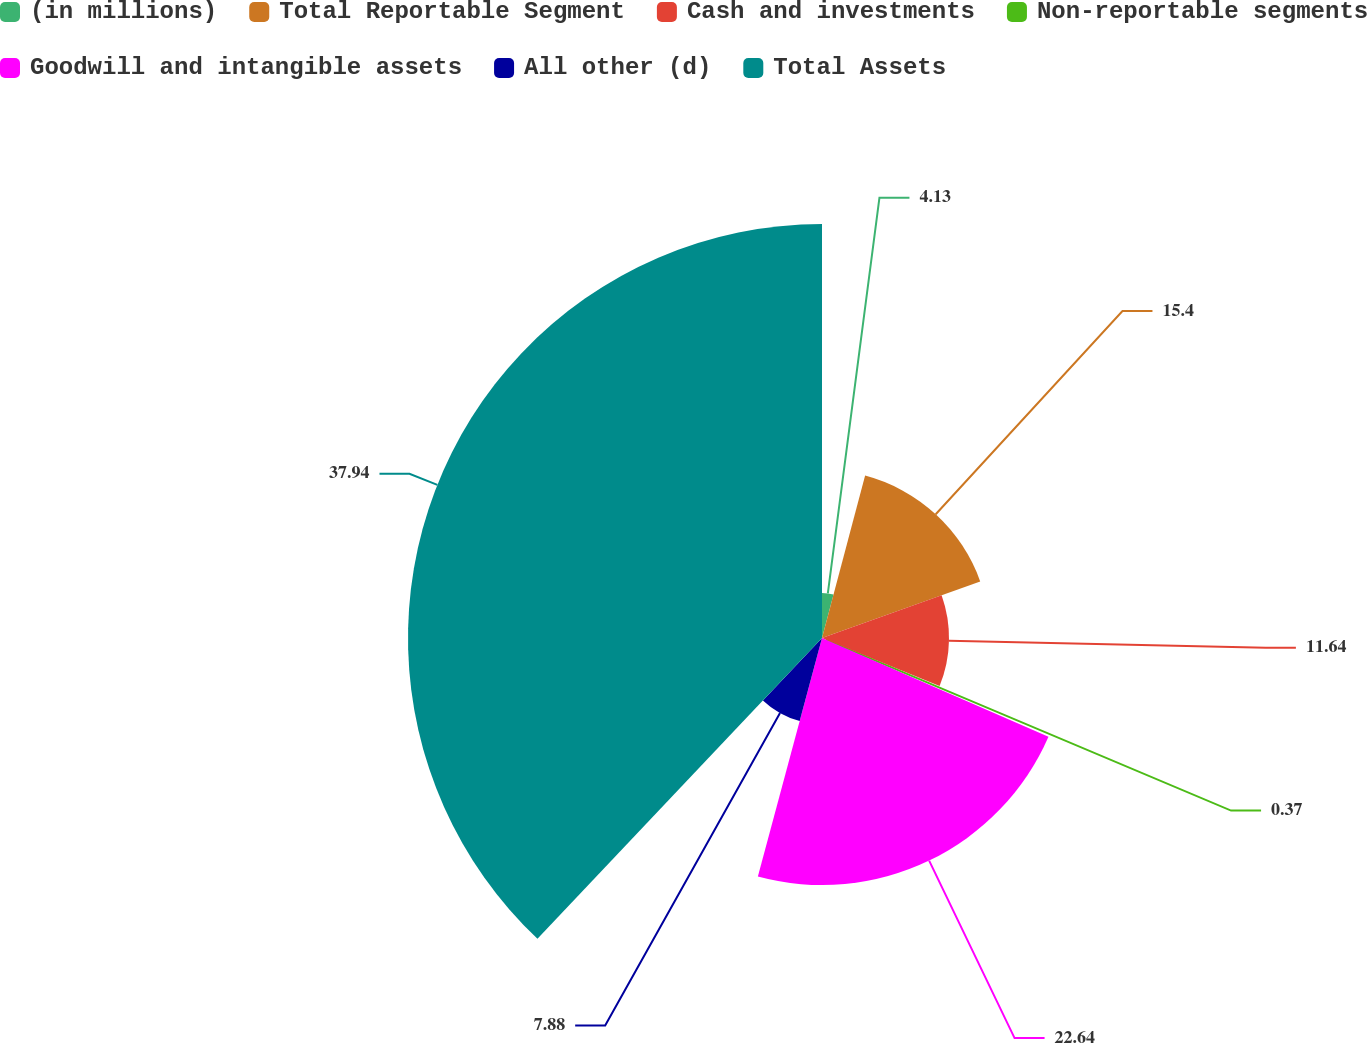Convert chart to OTSL. <chart><loc_0><loc_0><loc_500><loc_500><pie_chart><fcel>(in millions)<fcel>Total Reportable Segment<fcel>Cash and investments<fcel>Non-reportable segments<fcel>Goodwill and intangible assets<fcel>All other (d)<fcel>Total Assets<nl><fcel>4.13%<fcel>15.4%<fcel>11.64%<fcel>0.37%<fcel>22.64%<fcel>7.88%<fcel>37.94%<nl></chart> 